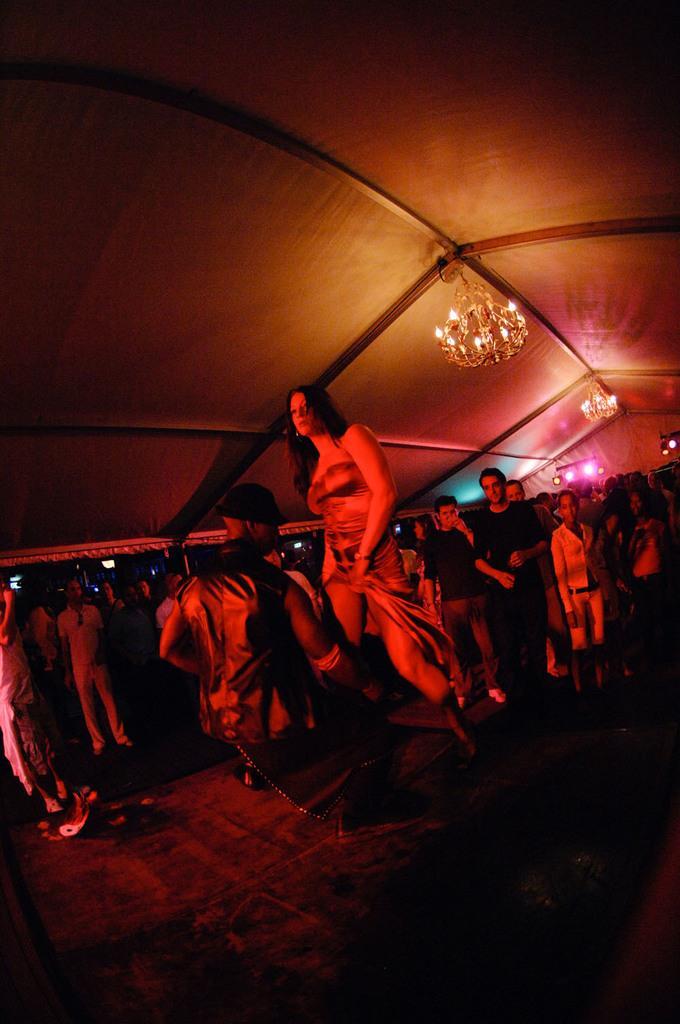Can you describe this image briefly? In the image there are few men and women standing and walking on the land and above there are chandeliers to the ceiling. 